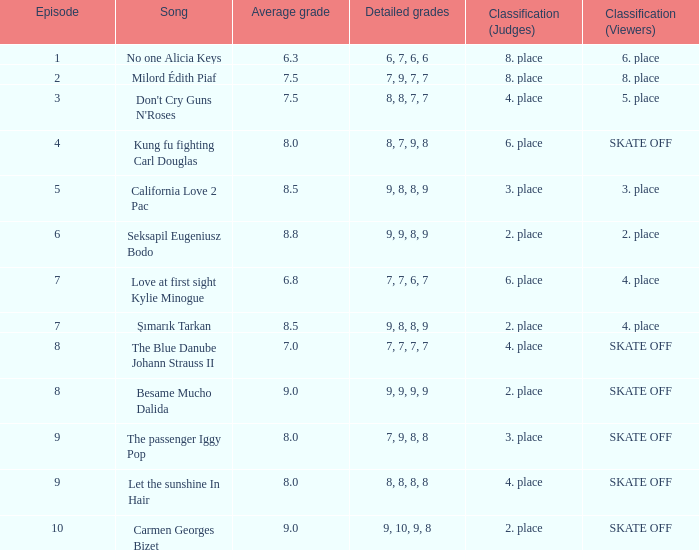Name the average grade for şımarık tarkan 8.5. 